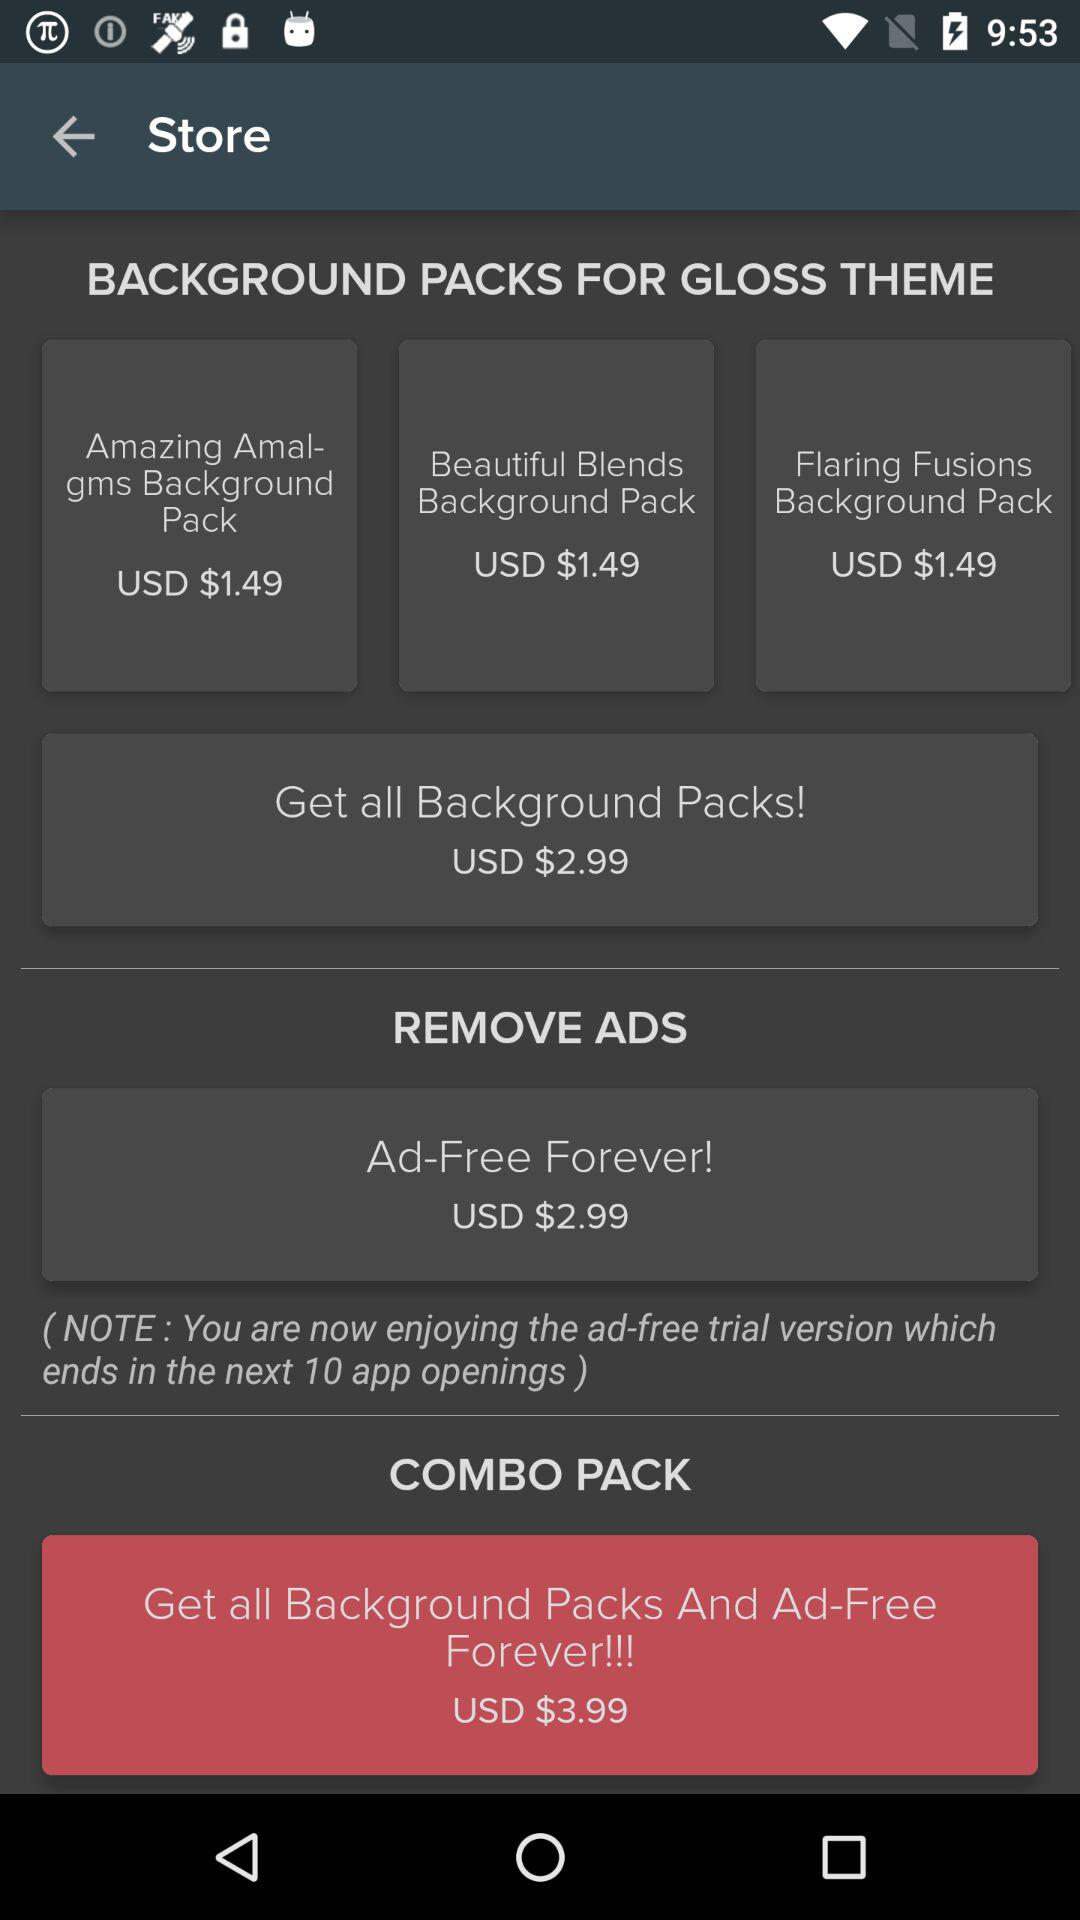What is the price of "Get all Background Packs And Ad-Free Forever!!!"? The price of "Get all Background Packs And Ad-Free Forever!!!" is USD $3.99. 